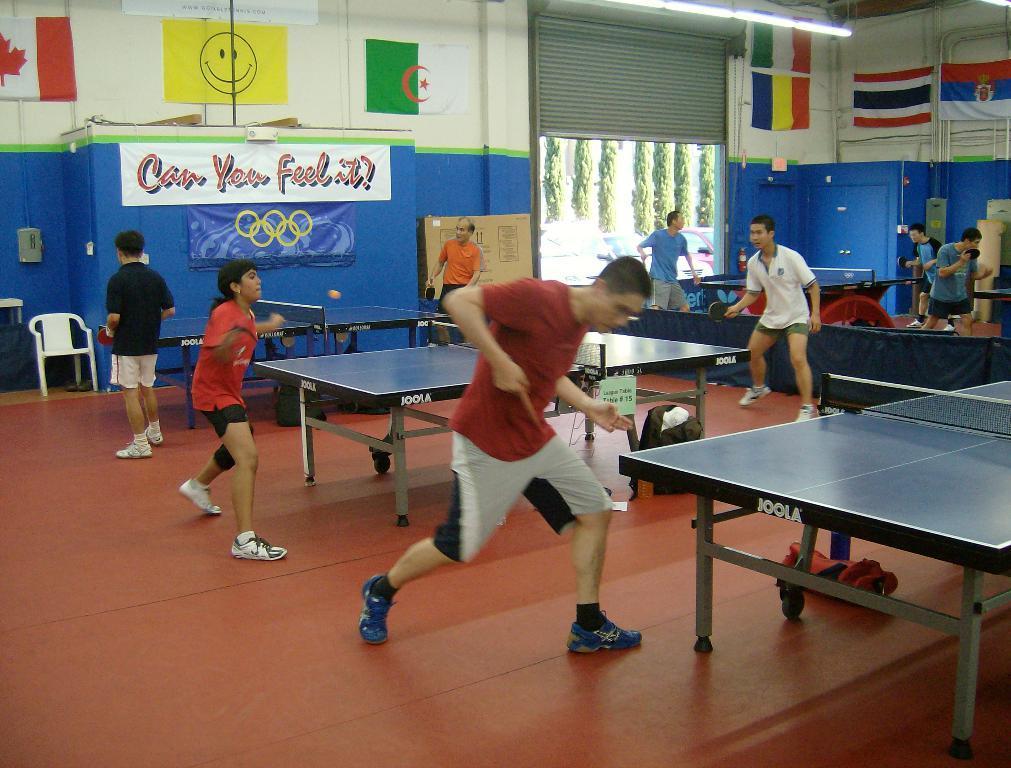How would you summarize this image in a sentence or two? In this picture we can see a group of people playing table tennis and aside to that table we have bags and in background we can see chair, wall with poster, shutter, flags. 